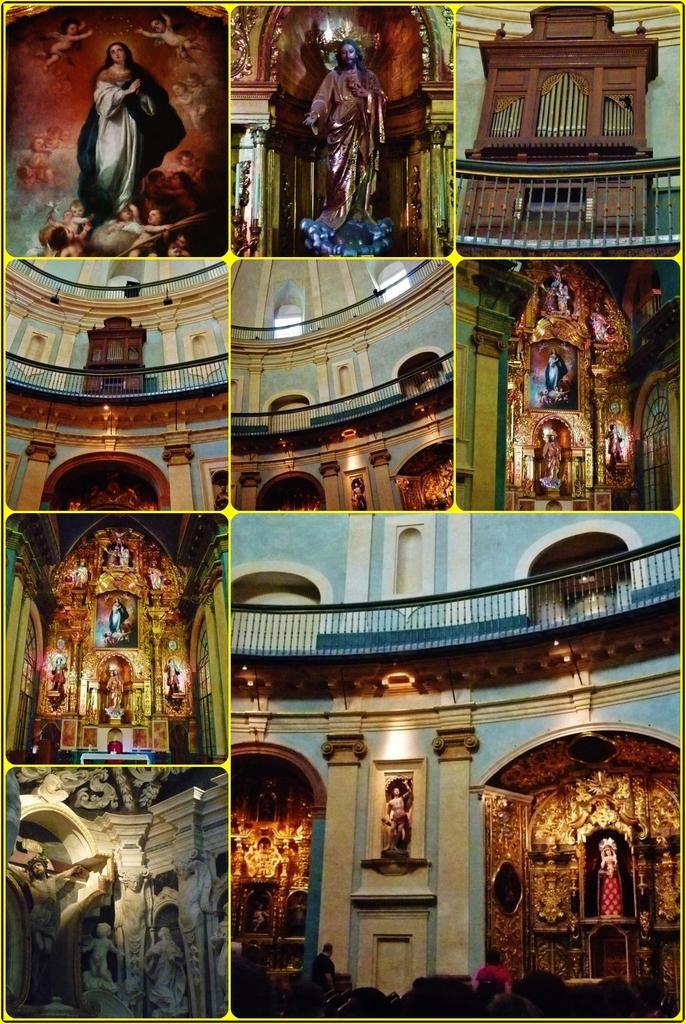Can you describe this image briefly? I see this is a collage image and I see number of sculptures of human being and I see the railing and I see the lights and I see the wall and I see the brown color cupboard over here. 